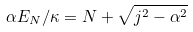<formula> <loc_0><loc_0><loc_500><loc_500>\alpha E _ { N } / \kappa = N + \sqrt { j ^ { 2 } - \alpha ^ { 2 } }</formula> 